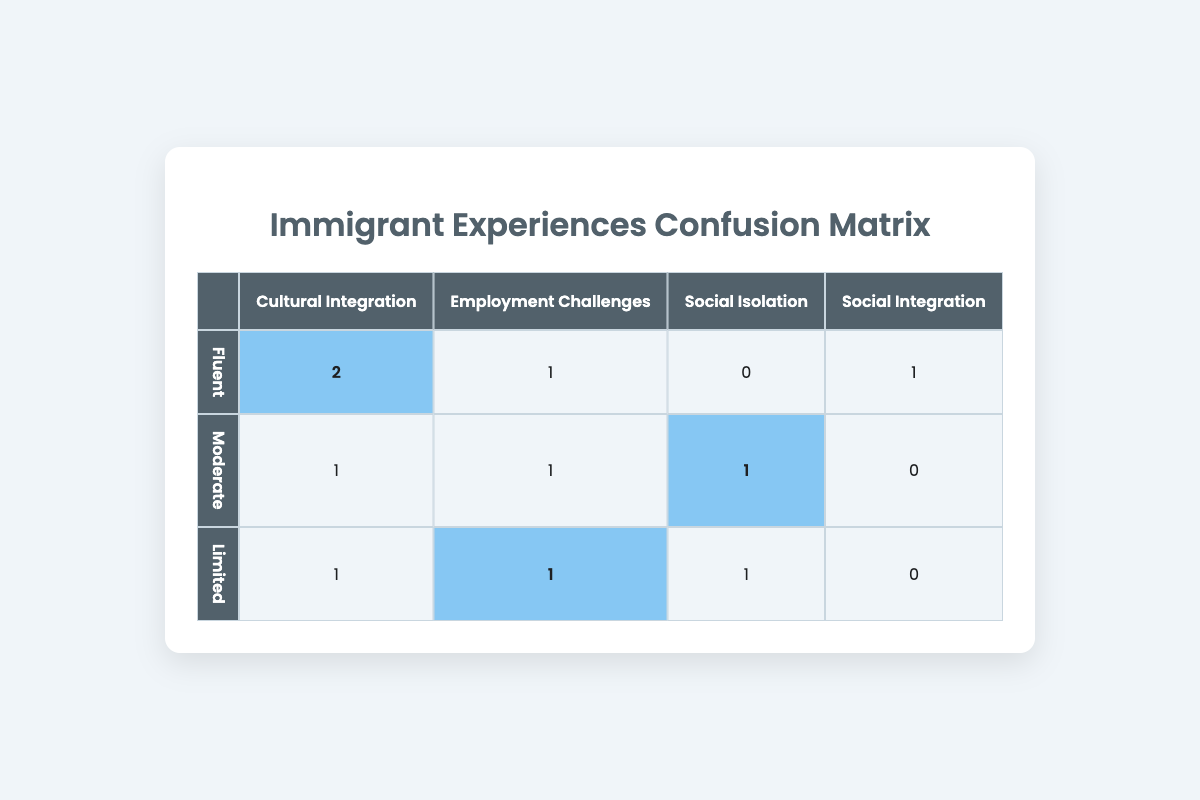What is the total number of participants who reported "Cultural Integration"? Looking at the "Cultural Integration" column, the row for "Fluent" shows 2, the row for "Moderate" shows 1, and the row for "Limited" shows 1. Summing these values gives 2 + 1 + 1 = 4.
Answer: 4 How many participants with "Limited" language proficiency reported "Employment Challenges"? Referring to the "Limited" row, we see that the "Employment Challenges" column shows a count of 1.
Answer: 1 Is there any participant with "Moderate" language proficiency who reported "Social Integration"? Looking at the "Moderate" row, the column for "Social Integration" shows a count of 0, meaning no participants with "Moderate" proficiency reported that experience.
Answer: No What is the difference in the number of participants reporting "Social Isolation" between "Fluent" and "Limited" language proficiency? The count for "Social Isolation" in the "Fluent" row is 0, while it is 1 for the "Limited" row. So, the difference is 1 - 0 = 1.
Answer: 1 What is the total number of participants who reported any form of "Employment Challenges"? The "Employment Challenges" column shows counts of 1 for "Fluent", 1 for "Moderate", and 1 for "Limited". Adding these values gives 1 + 1 + 1 = 3.
Answer: 3 Which language proficiency level has the highest reported experiences in "Cultural Integration"? In the "Cultural Integration" row, "Fluent" has 2, "Moderate" has 1, and "Limited" has 1. The highest count is 2, which is for "Fluent".
Answer: Fluent How many total participants reported any experience in "Social Integration"? Checking the "Social Integration" column, only the "Fluent" row has a count of 1, while others have 0. Therefore, the total is 1.
Answer: 1 What is the average number of participants reporting "Employment Challenges" across all language proficiencies? The counts in the "Employment Challenges" column are 1 for "Fluent", 1 for "Moderate", and 1 for "Limited". The total is 1 + 1 + 1 = 3. Since there are 3 language proficiency levels, the average is 3 / 3 = 1.
Answer: 1 